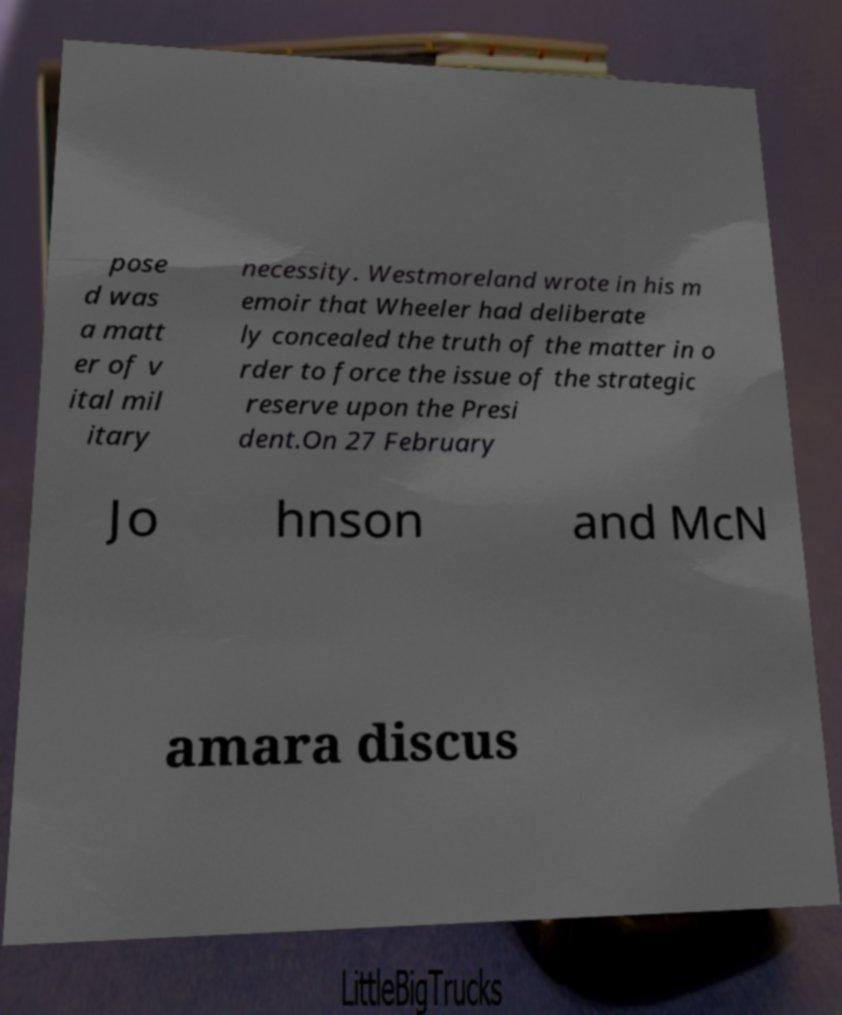Can you accurately transcribe the text from the provided image for me? pose d was a matt er of v ital mil itary necessity. Westmoreland wrote in his m emoir that Wheeler had deliberate ly concealed the truth of the matter in o rder to force the issue of the strategic reserve upon the Presi dent.On 27 February Jo hnson and McN amara discus 